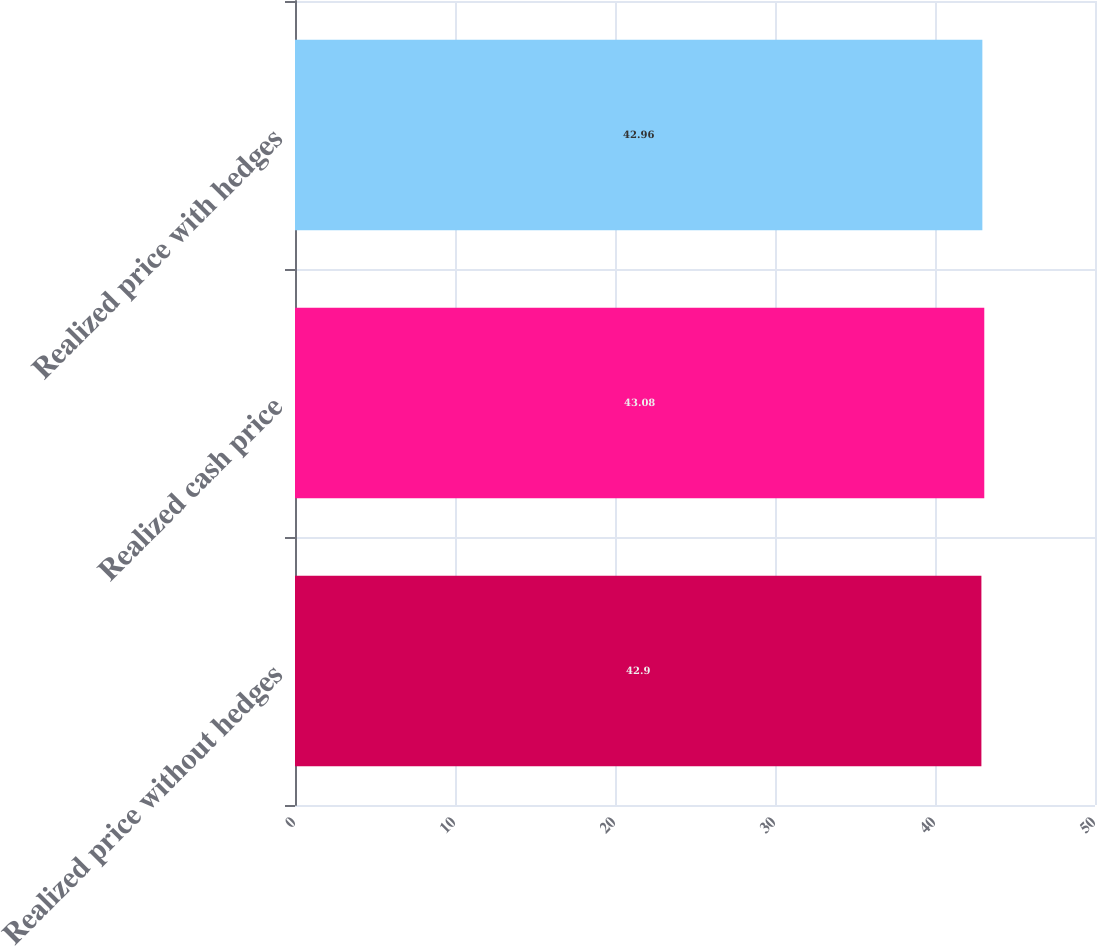Convert chart. <chart><loc_0><loc_0><loc_500><loc_500><bar_chart><fcel>Realized price without hedges<fcel>Realized cash price<fcel>Realized price with hedges<nl><fcel>42.9<fcel>43.08<fcel>42.96<nl></chart> 